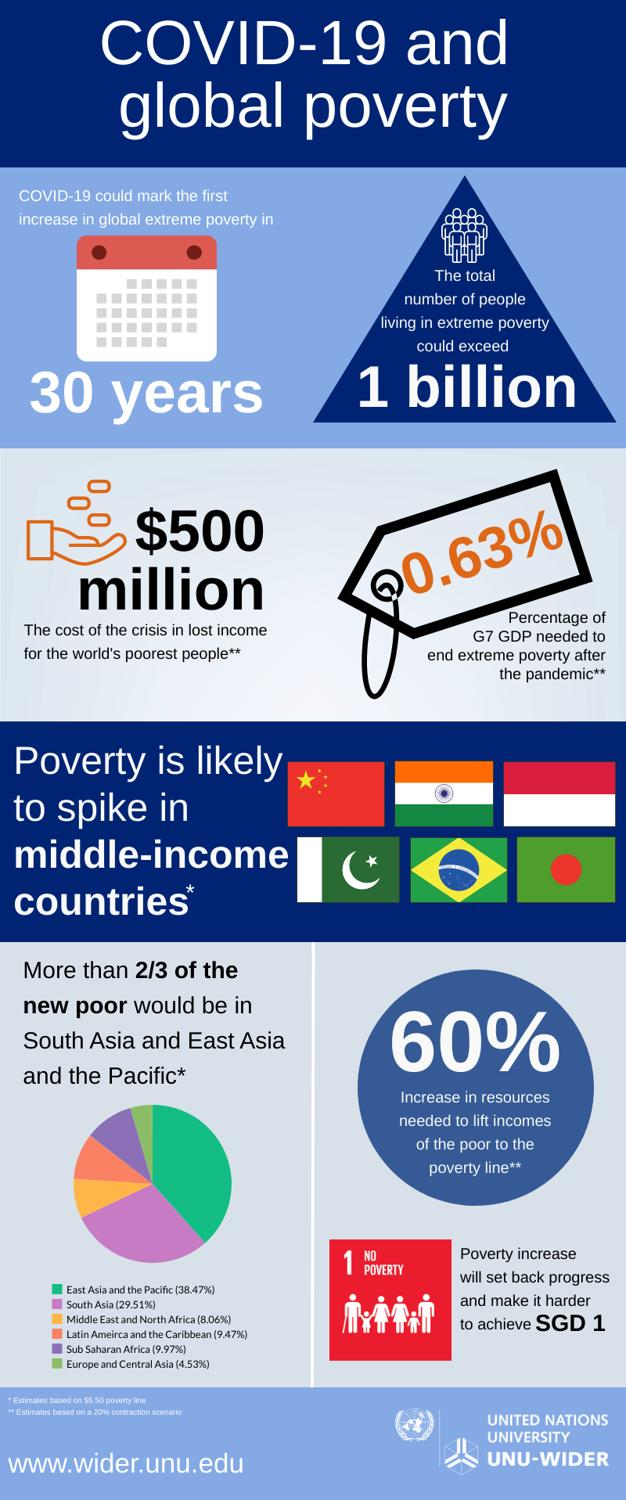List a handful of essential elements in this visual. In order to improve the living conditions of the poor, a significant reduction in the resources required is necessary. India is expected to be the second country to experience a poverty spike after the pandemic, following China, Thailand, and Japan. The Gross Domestic Product requires only 0.63% to effectively address the pandemic crisis. The Middle East and North Africa is predicted to be the third poorest region in the near future due to the pandemic's impact on its economy. The region of Latin America and the Caribbean is expected to experience economic hardship in the near future due to the pandemic, with some countries predicted to be particularly vulnerable, including one that is set to be the fourth-poorest in the world. 